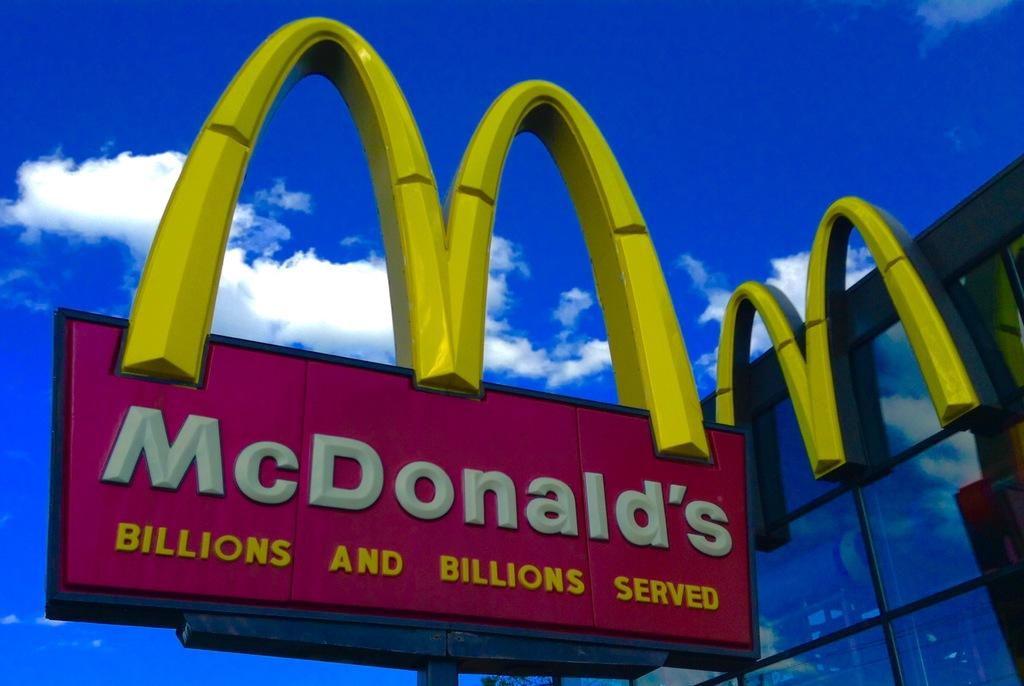<image>
Describe the image concisely. Mcdonald's billions and billions served sign on a building. 